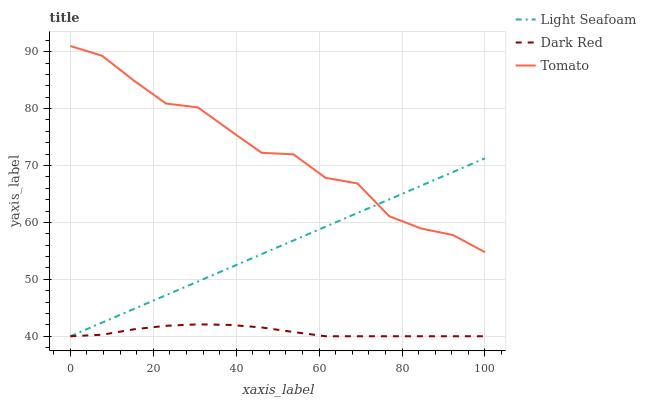Does Dark Red have the minimum area under the curve?
Answer yes or no. Yes. Does Tomato have the maximum area under the curve?
Answer yes or no. Yes. Does Light Seafoam have the minimum area under the curve?
Answer yes or no. No. Does Light Seafoam have the maximum area under the curve?
Answer yes or no. No. Is Light Seafoam the smoothest?
Answer yes or no. Yes. Is Tomato the roughest?
Answer yes or no. Yes. Is Dark Red the smoothest?
Answer yes or no. No. Is Dark Red the roughest?
Answer yes or no. No. Does Dark Red have the lowest value?
Answer yes or no. Yes. Does Tomato have the highest value?
Answer yes or no. Yes. Does Light Seafoam have the highest value?
Answer yes or no. No. Is Dark Red less than Tomato?
Answer yes or no. Yes. Is Tomato greater than Dark Red?
Answer yes or no. Yes. Does Dark Red intersect Light Seafoam?
Answer yes or no. Yes. Is Dark Red less than Light Seafoam?
Answer yes or no. No. Is Dark Red greater than Light Seafoam?
Answer yes or no. No. Does Dark Red intersect Tomato?
Answer yes or no. No. 